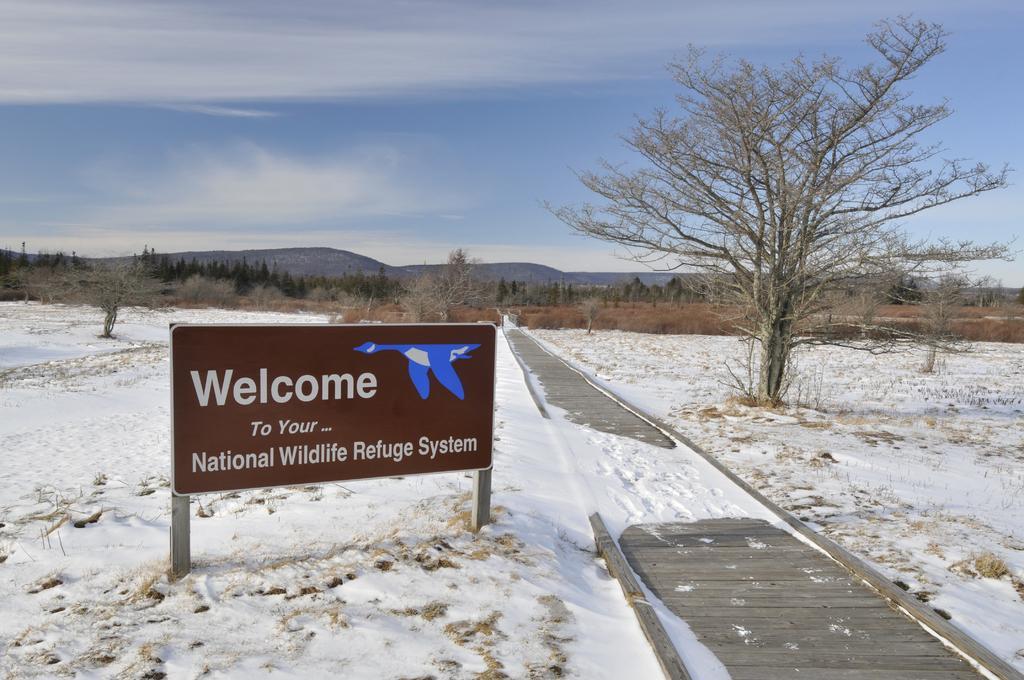Please provide a concise description of this image. In the picture we can see a wooden pathway on the other side of the path we can see a snow surface with a board on it, we can see welcome to your national wildlife refuge system, and on the other side we can see a dried tree and in the background also we can see trees, hills and sky. 